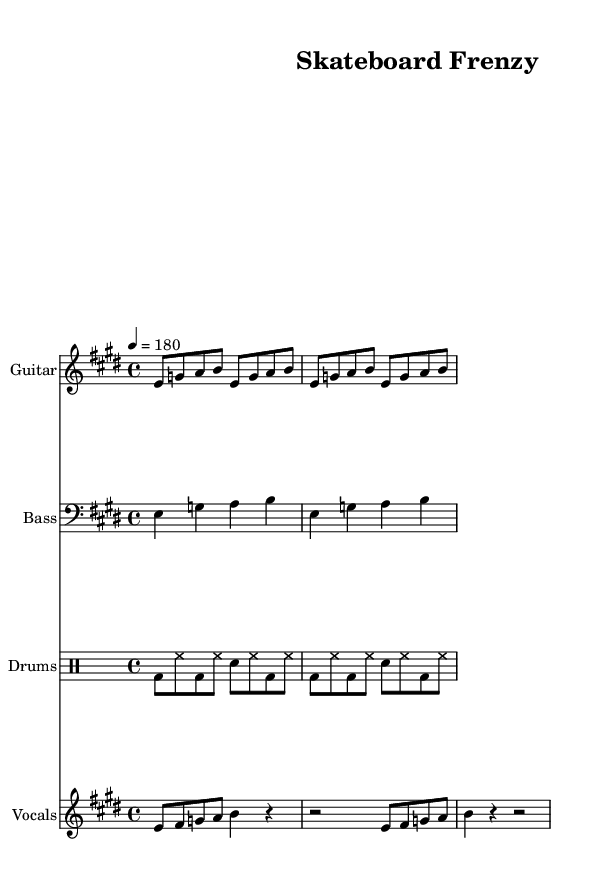What is the key signature of this music? The key signature is E major, which has four sharps: F#, C#, G#, and D#. The sharp signs are indicated at the beginning of the staff, confirming the key.
Answer: E major What is the time signature of this music? The time signature is 4/4, which is indicated at the beginning of the score with a numerator of four and a denominator of four. This means there are four beats in every measure, with the quarter note receiving one beat.
Answer: 4/4 What is the tempo marking for this piece? The tempo marking is 180 beats per minute (BPM), as noted in the tempo instruction at the beginning of the score. This indicates the speed at which the piece should be played.
Answer: 180 How many measures are in the vocal melody? The vocal melody consists of four measures. Each bar is denoted by vertical lines, and counting the segments shows that there are four complete measures throughout the melody part.
Answer: Four Which instrument plays the guitar riff? The guitar riff is played by the Guitar, as indicated by the instrument name at the top of the staff for the first part. This specifies which instrument is responsible for that line of music.
Answer: Guitar What type of rhythm is predominantly used in the drum pattern? The drum pattern predominantly uses eighth notes, as evident from the notation in the drum staff where the bass drum (bd), hi-hat (hh), and snare (sn) are all written in eighth note pairs, creating a fast-paced rhythmic feel typical of skate punk.
Answer: Eighth notes What is the style of music represented in this score? The style represented in this score is skate punk, characterized by high energy, fast tempos, and straightforward chord progressions, which aligns with the elements drawn from the robust guitar riffs and the driving beat of the drums.
Answer: Skate punk 